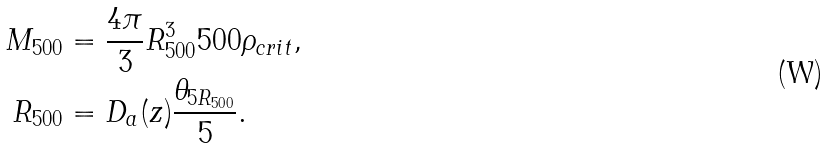Convert formula to latex. <formula><loc_0><loc_0><loc_500><loc_500>M _ { 5 0 0 } & = \frac { 4 \pi } { 3 } R _ { 5 0 0 } ^ { 3 } 5 0 0 \rho _ { c r i t } , \\ R _ { 5 0 0 } & = D _ { a } ( z ) \frac { \theta _ { 5 R _ { 5 0 0 } } } { 5 } .</formula> 